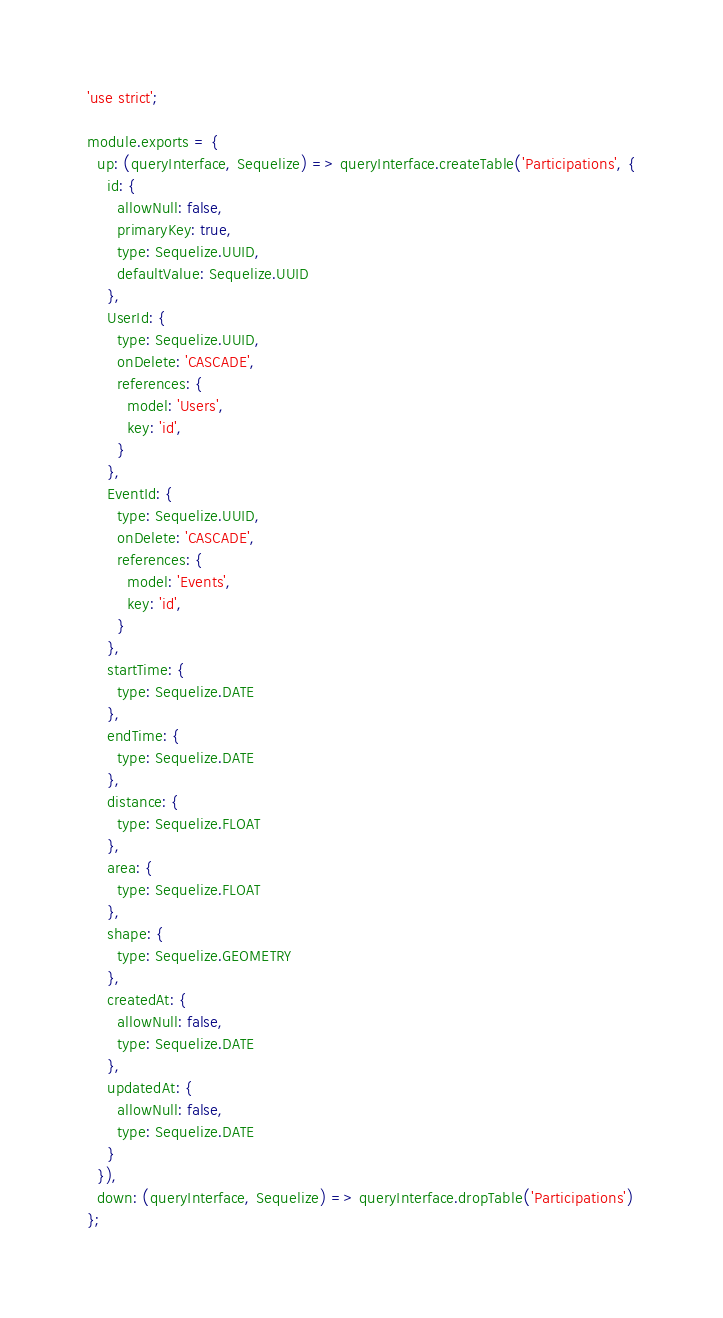<code> <loc_0><loc_0><loc_500><loc_500><_JavaScript_>'use strict';

module.exports = {
  up: (queryInterface, Sequelize) => queryInterface.createTable('Participations', {
    id: {
      allowNull: false,
      primaryKey: true,
      type: Sequelize.UUID,
      defaultValue: Sequelize.UUID
    },
    UserId: {
      type: Sequelize.UUID,
      onDelete: 'CASCADE',
      references: {
        model: 'Users',
        key: 'id',
      }
    },
    EventId: {
      type: Sequelize.UUID,
      onDelete: 'CASCADE',
      references: {
        model: 'Events',
        key: 'id',
      }
    },
    startTime: {
      type: Sequelize.DATE
    },
    endTime: {
      type: Sequelize.DATE
    },
    distance: {
      type: Sequelize.FLOAT
    },
    area: {
      type: Sequelize.FLOAT
    },
    shape: {
      type: Sequelize.GEOMETRY
    },
    createdAt: {
      allowNull: false,
      type: Sequelize.DATE
    },
    updatedAt: {
      allowNull: false,
      type: Sequelize.DATE
    }
  }),
  down: (queryInterface, Sequelize) => queryInterface.dropTable('Participations')
};
</code> 